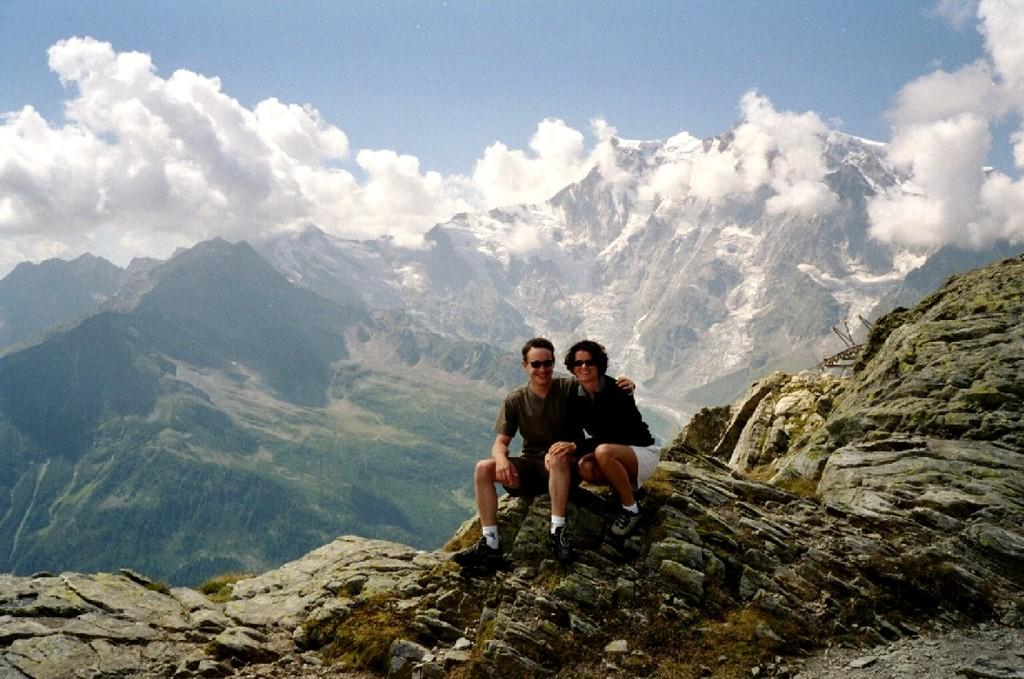How many people are in the image? There are two people in the image. Where are the people located in the image? The people are sitting on a hilltop. What can be seen in the background of the image? There are mountains visible in the background of the image. What type of music can be heard playing in the image? There is no music present in the image; it is a visual representation of two people sitting on a hilltop with mountains in the background. 